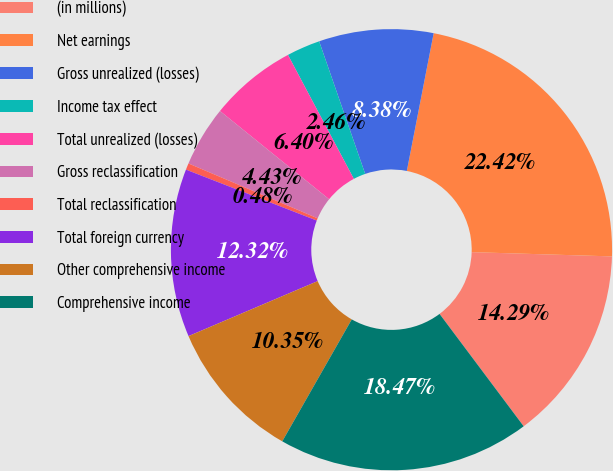Convert chart to OTSL. <chart><loc_0><loc_0><loc_500><loc_500><pie_chart><fcel>(in millions)<fcel>Net earnings<fcel>Gross unrealized (losses)<fcel>Income tax effect<fcel>Total unrealized (losses)<fcel>Gross reclassification<fcel>Total reclassification<fcel>Total foreign currency<fcel>Other comprehensive income<fcel>Comprehensive income<nl><fcel>14.29%<fcel>22.42%<fcel>8.38%<fcel>2.46%<fcel>6.4%<fcel>4.43%<fcel>0.48%<fcel>12.32%<fcel>10.35%<fcel>18.47%<nl></chart> 